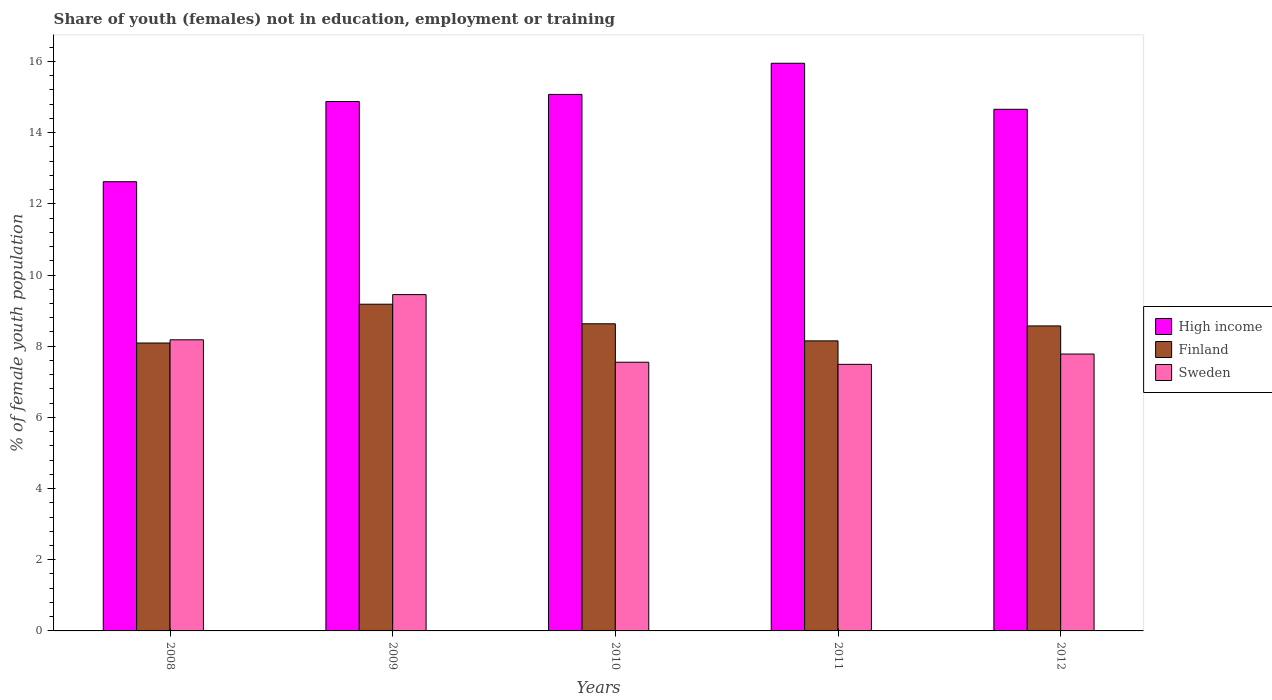How many groups of bars are there?
Your response must be concise. 5. How many bars are there on the 5th tick from the left?
Give a very brief answer. 3. How many bars are there on the 5th tick from the right?
Provide a short and direct response. 3. In how many cases, is the number of bars for a given year not equal to the number of legend labels?
Keep it short and to the point. 0. What is the percentage of unemployed female population in in Finland in 2011?
Offer a terse response. 8.15. Across all years, what is the maximum percentage of unemployed female population in in High income?
Keep it short and to the point. 15.95. Across all years, what is the minimum percentage of unemployed female population in in High income?
Provide a short and direct response. 12.62. In which year was the percentage of unemployed female population in in Sweden maximum?
Keep it short and to the point. 2009. In which year was the percentage of unemployed female population in in High income minimum?
Your answer should be very brief. 2008. What is the total percentage of unemployed female population in in High income in the graph?
Provide a short and direct response. 73.18. What is the difference between the percentage of unemployed female population in in Sweden in 2010 and that in 2011?
Your answer should be very brief. 0.06. What is the difference between the percentage of unemployed female population in in High income in 2011 and the percentage of unemployed female population in in Finland in 2009?
Ensure brevity in your answer.  6.77. What is the average percentage of unemployed female population in in High income per year?
Keep it short and to the point. 14.64. In the year 2009, what is the difference between the percentage of unemployed female population in in Finland and percentage of unemployed female population in in High income?
Your response must be concise. -5.69. In how many years, is the percentage of unemployed female population in in Sweden greater than 7.6 %?
Ensure brevity in your answer.  3. What is the ratio of the percentage of unemployed female population in in Sweden in 2008 to that in 2012?
Give a very brief answer. 1.05. Is the percentage of unemployed female population in in Sweden in 2009 less than that in 2010?
Offer a terse response. No. Is the difference between the percentage of unemployed female population in in Finland in 2009 and 2012 greater than the difference between the percentage of unemployed female population in in High income in 2009 and 2012?
Ensure brevity in your answer.  Yes. What is the difference between the highest and the second highest percentage of unemployed female population in in Sweden?
Offer a terse response. 1.27. What is the difference between the highest and the lowest percentage of unemployed female population in in Sweden?
Provide a succinct answer. 1.96. In how many years, is the percentage of unemployed female population in in High income greater than the average percentage of unemployed female population in in High income taken over all years?
Give a very brief answer. 4. What does the 1st bar from the right in 2008 represents?
Offer a very short reply. Sweden. How many bars are there?
Your answer should be very brief. 15. Are all the bars in the graph horizontal?
Offer a very short reply. No. Are the values on the major ticks of Y-axis written in scientific E-notation?
Your response must be concise. No. Does the graph contain any zero values?
Give a very brief answer. No. How are the legend labels stacked?
Provide a short and direct response. Vertical. What is the title of the graph?
Make the answer very short. Share of youth (females) not in education, employment or training. Does "Burkina Faso" appear as one of the legend labels in the graph?
Offer a terse response. No. What is the label or title of the Y-axis?
Your response must be concise. % of female youth population. What is the % of female youth population in High income in 2008?
Your answer should be very brief. 12.62. What is the % of female youth population of Finland in 2008?
Offer a very short reply. 8.09. What is the % of female youth population of Sweden in 2008?
Your answer should be very brief. 8.18. What is the % of female youth population in High income in 2009?
Your answer should be very brief. 14.87. What is the % of female youth population of Finland in 2009?
Your answer should be compact. 9.18. What is the % of female youth population of Sweden in 2009?
Your answer should be compact. 9.45. What is the % of female youth population in High income in 2010?
Provide a succinct answer. 15.07. What is the % of female youth population in Finland in 2010?
Your response must be concise. 8.63. What is the % of female youth population of Sweden in 2010?
Keep it short and to the point. 7.55. What is the % of female youth population of High income in 2011?
Keep it short and to the point. 15.95. What is the % of female youth population of Finland in 2011?
Ensure brevity in your answer.  8.15. What is the % of female youth population of Sweden in 2011?
Offer a terse response. 7.49. What is the % of female youth population of High income in 2012?
Ensure brevity in your answer.  14.66. What is the % of female youth population in Finland in 2012?
Provide a short and direct response. 8.57. What is the % of female youth population in Sweden in 2012?
Give a very brief answer. 7.78. Across all years, what is the maximum % of female youth population of High income?
Ensure brevity in your answer.  15.95. Across all years, what is the maximum % of female youth population of Finland?
Offer a terse response. 9.18. Across all years, what is the maximum % of female youth population of Sweden?
Offer a very short reply. 9.45. Across all years, what is the minimum % of female youth population in High income?
Your response must be concise. 12.62. Across all years, what is the minimum % of female youth population in Finland?
Offer a very short reply. 8.09. Across all years, what is the minimum % of female youth population of Sweden?
Ensure brevity in your answer.  7.49. What is the total % of female youth population of High income in the graph?
Make the answer very short. 73.18. What is the total % of female youth population of Finland in the graph?
Ensure brevity in your answer.  42.62. What is the total % of female youth population in Sweden in the graph?
Make the answer very short. 40.45. What is the difference between the % of female youth population of High income in 2008 and that in 2009?
Ensure brevity in your answer.  -2.25. What is the difference between the % of female youth population in Finland in 2008 and that in 2009?
Offer a very short reply. -1.09. What is the difference between the % of female youth population in Sweden in 2008 and that in 2009?
Offer a very short reply. -1.27. What is the difference between the % of female youth population in High income in 2008 and that in 2010?
Your response must be concise. -2.45. What is the difference between the % of female youth population in Finland in 2008 and that in 2010?
Keep it short and to the point. -0.54. What is the difference between the % of female youth population of Sweden in 2008 and that in 2010?
Your response must be concise. 0.63. What is the difference between the % of female youth population in High income in 2008 and that in 2011?
Your answer should be compact. -3.33. What is the difference between the % of female youth population of Finland in 2008 and that in 2011?
Make the answer very short. -0.06. What is the difference between the % of female youth population of Sweden in 2008 and that in 2011?
Your answer should be compact. 0.69. What is the difference between the % of female youth population of High income in 2008 and that in 2012?
Make the answer very short. -2.04. What is the difference between the % of female youth population of Finland in 2008 and that in 2012?
Offer a terse response. -0.48. What is the difference between the % of female youth population of Sweden in 2008 and that in 2012?
Provide a short and direct response. 0.4. What is the difference between the % of female youth population of High income in 2009 and that in 2010?
Your answer should be very brief. -0.2. What is the difference between the % of female youth population of Finland in 2009 and that in 2010?
Ensure brevity in your answer.  0.55. What is the difference between the % of female youth population in High income in 2009 and that in 2011?
Your response must be concise. -1.08. What is the difference between the % of female youth population in Sweden in 2009 and that in 2011?
Make the answer very short. 1.96. What is the difference between the % of female youth population in High income in 2009 and that in 2012?
Keep it short and to the point. 0.22. What is the difference between the % of female youth population of Finland in 2009 and that in 2012?
Your response must be concise. 0.61. What is the difference between the % of female youth population in Sweden in 2009 and that in 2012?
Your response must be concise. 1.67. What is the difference between the % of female youth population of High income in 2010 and that in 2011?
Your response must be concise. -0.88. What is the difference between the % of female youth population in Finland in 2010 and that in 2011?
Offer a terse response. 0.48. What is the difference between the % of female youth population in High income in 2010 and that in 2012?
Your answer should be very brief. 0.42. What is the difference between the % of female youth population of Finland in 2010 and that in 2012?
Your answer should be compact. 0.06. What is the difference between the % of female youth population of Sweden in 2010 and that in 2012?
Your answer should be very brief. -0.23. What is the difference between the % of female youth population of High income in 2011 and that in 2012?
Your answer should be very brief. 1.29. What is the difference between the % of female youth population of Finland in 2011 and that in 2012?
Provide a succinct answer. -0.42. What is the difference between the % of female youth population in Sweden in 2011 and that in 2012?
Ensure brevity in your answer.  -0.29. What is the difference between the % of female youth population in High income in 2008 and the % of female youth population in Finland in 2009?
Ensure brevity in your answer.  3.44. What is the difference between the % of female youth population of High income in 2008 and the % of female youth population of Sweden in 2009?
Give a very brief answer. 3.17. What is the difference between the % of female youth population of Finland in 2008 and the % of female youth population of Sweden in 2009?
Ensure brevity in your answer.  -1.36. What is the difference between the % of female youth population of High income in 2008 and the % of female youth population of Finland in 2010?
Give a very brief answer. 3.99. What is the difference between the % of female youth population in High income in 2008 and the % of female youth population in Sweden in 2010?
Offer a terse response. 5.07. What is the difference between the % of female youth population of Finland in 2008 and the % of female youth population of Sweden in 2010?
Offer a very short reply. 0.54. What is the difference between the % of female youth population in High income in 2008 and the % of female youth population in Finland in 2011?
Your answer should be very brief. 4.47. What is the difference between the % of female youth population of High income in 2008 and the % of female youth population of Sweden in 2011?
Offer a very short reply. 5.13. What is the difference between the % of female youth population in High income in 2008 and the % of female youth population in Finland in 2012?
Make the answer very short. 4.05. What is the difference between the % of female youth population in High income in 2008 and the % of female youth population in Sweden in 2012?
Give a very brief answer. 4.84. What is the difference between the % of female youth population of Finland in 2008 and the % of female youth population of Sweden in 2012?
Offer a terse response. 0.31. What is the difference between the % of female youth population of High income in 2009 and the % of female youth population of Finland in 2010?
Provide a succinct answer. 6.24. What is the difference between the % of female youth population in High income in 2009 and the % of female youth population in Sweden in 2010?
Keep it short and to the point. 7.32. What is the difference between the % of female youth population in Finland in 2009 and the % of female youth population in Sweden in 2010?
Your answer should be compact. 1.63. What is the difference between the % of female youth population of High income in 2009 and the % of female youth population of Finland in 2011?
Offer a very short reply. 6.72. What is the difference between the % of female youth population in High income in 2009 and the % of female youth population in Sweden in 2011?
Offer a terse response. 7.38. What is the difference between the % of female youth population of Finland in 2009 and the % of female youth population of Sweden in 2011?
Provide a short and direct response. 1.69. What is the difference between the % of female youth population in High income in 2009 and the % of female youth population in Finland in 2012?
Offer a terse response. 6.3. What is the difference between the % of female youth population of High income in 2009 and the % of female youth population of Sweden in 2012?
Provide a succinct answer. 7.09. What is the difference between the % of female youth population in High income in 2010 and the % of female youth population in Finland in 2011?
Your response must be concise. 6.92. What is the difference between the % of female youth population in High income in 2010 and the % of female youth population in Sweden in 2011?
Give a very brief answer. 7.58. What is the difference between the % of female youth population in Finland in 2010 and the % of female youth population in Sweden in 2011?
Offer a terse response. 1.14. What is the difference between the % of female youth population of High income in 2010 and the % of female youth population of Finland in 2012?
Make the answer very short. 6.5. What is the difference between the % of female youth population in High income in 2010 and the % of female youth population in Sweden in 2012?
Make the answer very short. 7.29. What is the difference between the % of female youth population in Finland in 2010 and the % of female youth population in Sweden in 2012?
Your answer should be very brief. 0.85. What is the difference between the % of female youth population of High income in 2011 and the % of female youth population of Finland in 2012?
Make the answer very short. 7.38. What is the difference between the % of female youth population of High income in 2011 and the % of female youth population of Sweden in 2012?
Keep it short and to the point. 8.17. What is the difference between the % of female youth population in Finland in 2011 and the % of female youth population in Sweden in 2012?
Your answer should be compact. 0.37. What is the average % of female youth population in High income per year?
Give a very brief answer. 14.64. What is the average % of female youth population of Finland per year?
Offer a very short reply. 8.52. What is the average % of female youth population in Sweden per year?
Your answer should be very brief. 8.09. In the year 2008, what is the difference between the % of female youth population in High income and % of female youth population in Finland?
Provide a short and direct response. 4.53. In the year 2008, what is the difference between the % of female youth population of High income and % of female youth population of Sweden?
Give a very brief answer. 4.44. In the year 2008, what is the difference between the % of female youth population in Finland and % of female youth population in Sweden?
Keep it short and to the point. -0.09. In the year 2009, what is the difference between the % of female youth population in High income and % of female youth population in Finland?
Offer a very short reply. 5.69. In the year 2009, what is the difference between the % of female youth population of High income and % of female youth population of Sweden?
Ensure brevity in your answer.  5.42. In the year 2009, what is the difference between the % of female youth population of Finland and % of female youth population of Sweden?
Your response must be concise. -0.27. In the year 2010, what is the difference between the % of female youth population of High income and % of female youth population of Finland?
Ensure brevity in your answer.  6.44. In the year 2010, what is the difference between the % of female youth population of High income and % of female youth population of Sweden?
Ensure brevity in your answer.  7.52. In the year 2010, what is the difference between the % of female youth population of Finland and % of female youth population of Sweden?
Your answer should be compact. 1.08. In the year 2011, what is the difference between the % of female youth population in High income and % of female youth population in Finland?
Ensure brevity in your answer.  7.8. In the year 2011, what is the difference between the % of female youth population in High income and % of female youth population in Sweden?
Ensure brevity in your answer.  8.46. In the year 2011, what is the difference between the % of female youth population of Finland and % of female youth population of Sweden?
Ensure brevity in your answer.  0.66. In the year 2012, what is the difference between the % of female youth population of High income and % of female youth population of Finland?
Your answer should be very brief. 6.09. In the year 2012, what is the difference between the % of female youth population of High income and % of female youth population of Sweden?
Your answer should be compact. 6.88. In the year 2012, what is the difference between the % of female youth population of Finland and % of female youth population of Sweden?
Offer a very short reply. 0.79. What is the ratio of the % of female youth population of High income in 2008 to that in 2009?
Provide a short and direct response. 0.85. What is the ratio of the % of female youth population of Finland in 2008 to that in 2009?
Your response must be concise. 0.88. What is the ratio of the % of female youth population in Sweden in 2008 to that in 2009?
Your answer should be compact. 0.87. What is the ratio of the % of female youth population in High income in 2008 to that in 2010?
Your response must be concise. 0.84. What is the ratio of the % of female youth population of Finland in 2008 to that in 2010?
Ensure brevity in your answer.  0.94. What is the ratio of the % of female youth population of Sweden in 2008 to that in 2010?
Provide a short and direct response. 1.08. What is the ratio of the % of female youth population of High income in 2008 to that in 2011?
Make the answer very short. 0.79. What is the ratio of the % of female youth population in Finland in 2008 to that in 2011?
Offer a terse response. 0.99. What is the ratio of the % of female youth population in Sweden in 2008 to that in 2011?
Your response must be concise. 1.09. What is the ratio of the % of female youth population of High income in 2008 to that in 2012?
Make the answer very short. 0.86. What is the ratio of the % of female youth population of Finland in 2008 to that in 2012?
Make the answer very short. 0.94. What is the ratio of the % of female youth population in Sweden in 2008 to that in 2012?
Your response must be concise. 1.05. What is the ratio of the % of female youth population of High income in 2009 to that in 2010?
Offer a terse response. 0.99. What is the ratio of the % of female youth population in Finland in 2009 to that in 2010?
Offer a terse response. 1.06. What is the ratio of the % of female youth population of Sweden in 2009 to that in 2010?
Offer a very short reply. 1.25. What is the ratio of the % of female youth population of High income in 2009 to that in 2011?
Make the answer very short. 0.93. What is the ratio of the % of female youth population of Finland in 2009 to that in 2011?
Provide a succinct answer. 1.13. What is the ratio of the % of female youth population in Sweden in 2009 to that in 2011?
Provide a succinct answer. 1.26. What is the ratio of the % of female youth population of High income in 2009 to that in 2012?
Give a very brief answer. 1.01. What is the ratio of the % of female youth population of Finland in 2009 to that in 2012?
Keep it short and to the point. 1.07. What is the ratio of the % of female youth population of Sweden in 2009 to that in 2012?
Offer a terse response. 1.21. What is the ratio of the % of female youth population of High income in 2010 to that in 2011?
Your answer should be very brief. 0.95. What is the ratio of the % of female youth population of Finland in 2010 to that in 2011?
Offer a very short reply. 1.06. What is the ratio of the % of female youth population of High income in 2010 to that in 2012?
Your answer should be compact. 1.03. What is the ratio of the % of female youth population in Finland in 2010 to that in 2012?
Offer a terse response. 1.01. What is the ratio of the % of female youth population in Sweden in 2010 to that in 2012?
Your response must be concise. 0.97. What is the ratio of the % of female youth population in High income in 2011 to that in 2012?
Your response must be concise. 1.09. What is the ratio of the % of female youth population of Finland in 2011 to that in 2012?
Provide a succinct answer. 0.95. What is the ratio of the % of female youth population of Sweden in 2011 to that in 2012?
Your response must be concise. 0.96. What is the difference between the highest and the second highest % of female youth population in High income?
Your answer should be very brief. 0.88. What is the difference between the highest and the second highest % of female youth population of Finland?
Your answer should be compact. 0.55. What is the difference between the highest and the second highest % of female youth population in Sweden?
Offer a terse response. 1.27. What is the difference between the highest and the lowest % of female youth population of High income?
Offer a very short reply. 3.33. What is the difference between the highest and the lowest % of female youth population in Finland?
Make the answer very short. 1.09. What is the difference between the highest and the lowest % of female youth population of Sweden?
Provide a succinct answer. 1.96. 